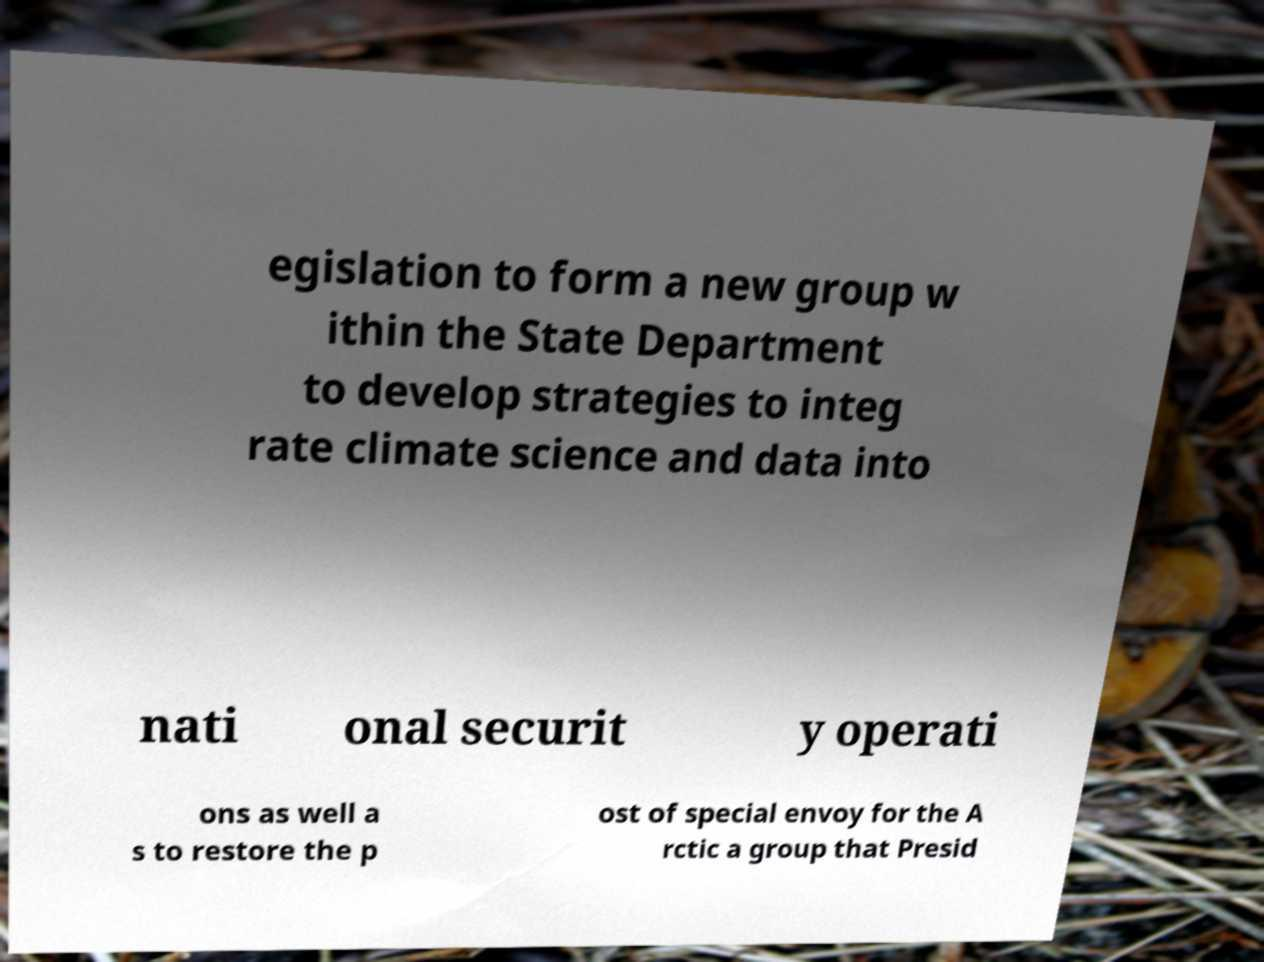For documentation purposes, I need the text within this image transcribed. Could you provide that? egislation to form a new group w ithin the State Department to develop strategies to integ rate climate science and data into nati onal securit y operati ons as well a s to restore the p ost of special envoy for the A rctic a group that Presid 